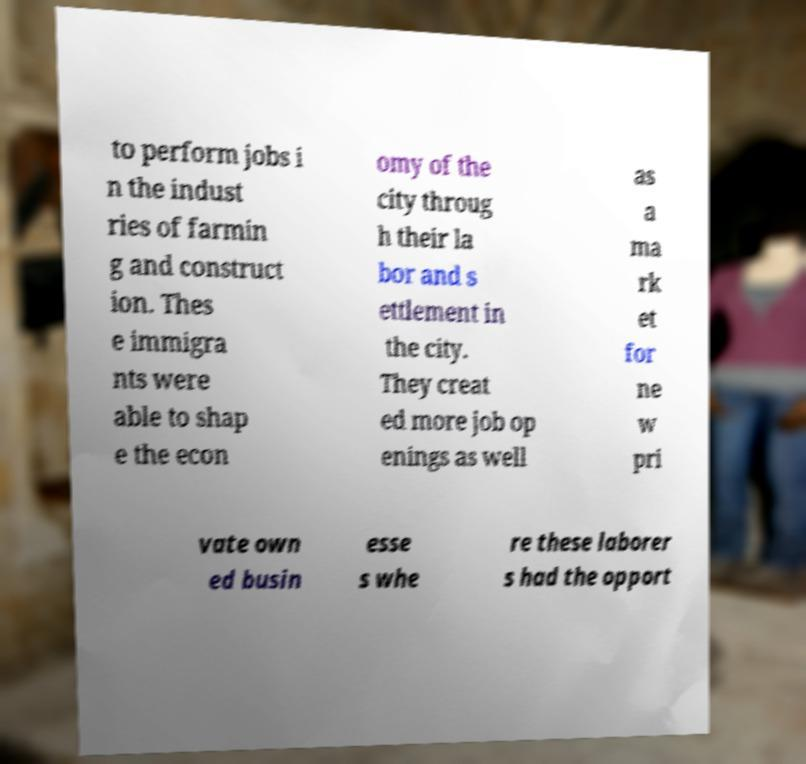Could you extract and type out the text from this image? to perform jobs i n the indust ries of farmin g and construct ion. Thes e immigra nts were able to shap e the econ omy of the city throug h their la bor and s ettlement in the city. They creat ed more job op enings as well as a ma rk et for ne w pri vate own ed busin esse s whe re these laborer s had the opport 